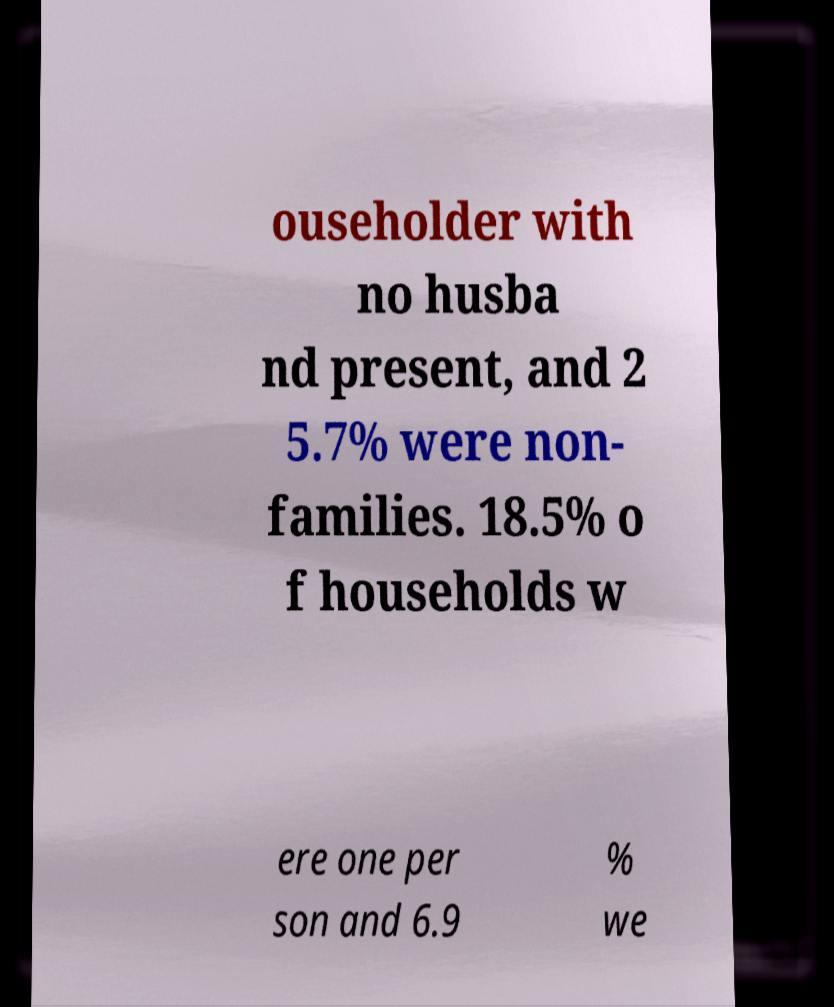Could you assist in decoding the text presented in this image and type it out clearly? ouseholder with no husba nd present, and 2 5.7% were non- families. 18.5% o f households w ere one per son and 6.9 % we 